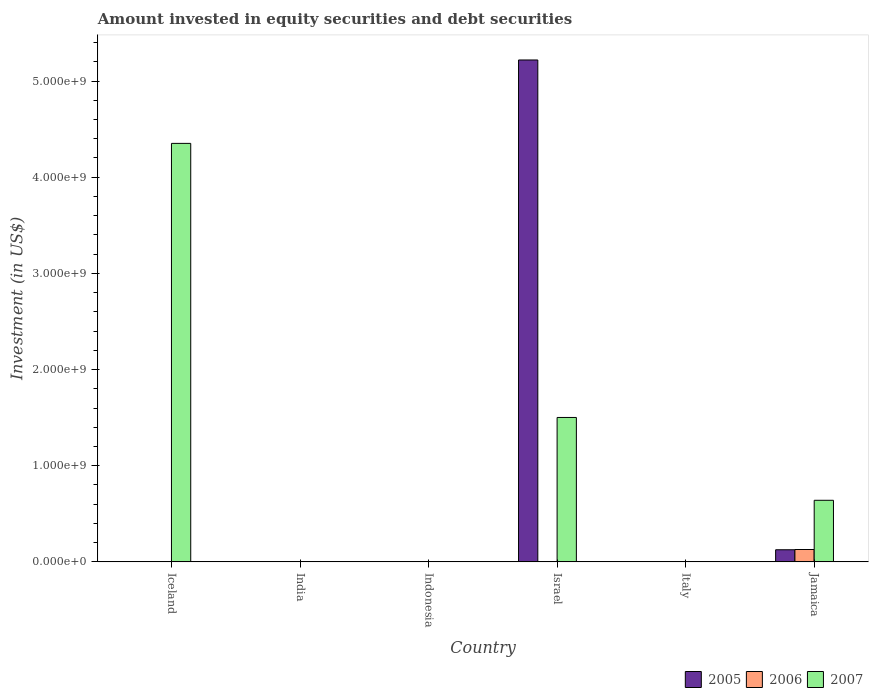How many different coloured bars are there?
Provide a succinct answer. 3. Are the number of bars per tick equal to the number of legend labels?
Provide a succinct answer. No. Are the number of bars on each tick of the X-axis equal?
Provide a short and direct response. No. How many bars are there on the 3rd tick from the left?
Your answer should be very brief. 0. How many bars are there on the 5th tick from the right?
Offer a very short reply. 0. In how many cases, is the number of bars for a given country not equal to the number of legend labels?
Offer a terse response. 5. What is the amount invested in equity securities and debt securities in 2006 in Italy?
Offer a very short reply. 0. Across all countries, what is the maximum amount invested in equity securities and debt securities in 2007?
Offer a very short reply. 4.35e+09. Across all countries, what is the minimum amount invested in equity securities and debt securities in 2007?
Offer a terse response. 0. What is the total amount invested in equity securities and debt securities in 2005 in the graph?
Provide a succinct answer. 5.34e+09. What is the difference between the amount invested in equity securities and debt securities in 2005 in Jamaica and the amount invested in equity securities and debt securities in 2006 in Iceland?
Provide a succinct answer. 1.26e+08. What is the average amount invested in equity securities and debt securities in 2005 per country?
Keep it short and to the point. 8.91e+08. What is the difference between the amount invested in equity securities and debt securities of/in 2006 and amount invested in equity securities and debt securities of/in 2005 in Jamaica?
Keep it short and to the point. 2.52e+06. In how many countries, is the amount invested in equity securities and debt securities in 2005 greater than 2000000000 US$?
Keep it short and to the point. 1. Is the amount invested in equity securities and debt securities in 2005 in Israel less than that in Jamaica?
Offer a very short reply. No. What is the difference between the highest and the second highest amount invested in equity securities and debt securities in 2007?
Give a very brief answer. -2.85e+09. What is the difference between the highest and the lowest amount invested in equity securities and debt securities in 2006?
Make the answer very short. 1.29e+08. In how many countries, is the amount invested in equity securities and debt securities in 2007 greater than the average amount invested in equity securities and debt securities in 2007 taken over all countries?
Your response must be concise. 2. Is it the case that in every country, the sum of the amount invested in equity securities and debt securities in 2007 and amount invested in equity securities and debt securities in 2006 is greater than the amount invested in equity securities and debt securities in 2005?
Provide a short and direct response. No. How many bars are there?
Offer a terse response. 6. Are all the bars in the graph horizontal?
Your response must be concise. No. Are the values on the major ticks of Y-axis written in scientific E-notation?
Your answer should be compact. Yes. Does the graph contain any zero values?
Offer a terse response. Yes. Does the graph contain grids?
Give a very brief answer. No. Where does the legend appear in the graph?
Provide a succinct answer. Bottom right. How many legend labels are there?
Your answer should be very brief. 3. How are the legend labels stacked?
Ensure brevity in your answer.  Horizontal. What is the title of the graph?
Provide a succinct answer. Amount invested in equity securities and debt securities. What is the label or title of the Y-axis?
Provide a succinct answer. Investment (in US$). What is the Investment (in US$) of 2006 in Iceland?
Offer a very short reply. 0. What is the Investment (in US$) in 2007 in Iceland?
Provide a short and direct response. 4.35e+09. What is the Investment (in US$) of 2007 in India?
Keep it short and to the point. 0. What is the Investment (in US$) of 2005 in Indonesia?
Offer a terse response. 0. What is the Investment (in US$) in 2006 in Indonesia?
Give a very brief answer. 0. What is the Investment (in US$) of 2005 in Israel?
Ensure brevity in your answer.  5.22e+09. What is the Investment (in US$) in 2006 in Israel?
Provide a short and direct response. 0. What is the Investment (in US$) of 2007 in Israel?
Offer a terse response. 1.50e+09. What is the Investment (in US$) in 2005 in Italy?
Provide a short and direct response. 0. What is the Investment (in US$) in 2006 in Italy?
Provide a succinct answer. 0. What is the Investment (in US$) of 2007 in Italy?
Provide a short and direct response. 0. What is the Investment (in US$) of 2005 in Jamaica?
Offer a terse response. 1.26e+08. What is the Investment (in US$) in 2006 in Jamaica?
Your response must be concise. 1.29e+08. What is the Investment (in US$) in 2007 in Jamaica?
Your answer should be very brief. 6.40e+08. Across all countries, what is the maximum Investment (in US$) in 2005?
Your answer should be very brief. 5.22e+09. Across all countries, what is the maximum Investment (in US$) of 2006?
Your answer should be compact. 1.29e+08. Across all countries, what is the maximum Investment (in US$) of 2007?
Offer a terse response. 4.35e+09. Across all countries, what is the minimum Investment (in US$) of 2006?
Keep it short and to the point. 0. What is the total Investment (in US$) in 2005 in the graph?
Your answer should be compact. 5.34e+09. What is the total Investment (in US$) of 2006 in the graph?
Provide a short and direct response. 1.29e+08. What is the total Investment (in US$) in 2007 in the graph?
Make the answer very short. 6.49e+09. What is the difference between the Investment (in US$) in 2007 in Iceland and that in Israel?
Offer a very short reply. 2.85e+09. What is the difference between the Investment (in US$) in 2007 in Iceland and that in Jamaica?
Your answer should be very brief. 3.71e+09. What is the difference between the Investment (in US$) of 2005 in Israel and that in Jamaica?
Offer a very short reply. 5.09e+09. What is the difference between the Investment (in US$) in 2007 in Israel and that in Jamaica?
Give a very brief answer. 8.61e+08. What is the difference between the Investment (in US$) of 2005 in Israel and the Investment (in US$) of 2006 in Jamaica?
Your response must be concise. 5.09e+09. What is the difference between the Investment (in US$) in 2005 in Israel and the Investment (in US$) in 2007 in Jamaica?
Your response must be concise. 4.58e+09. What is the average Investment (in US$) of 2005 per country?
Your answer should be very brief. 8.91e+08. What is the average Investment (in US$) in 2006 per country?
Offer a terse response. 2.14e+07. What is the average Investment (in US$) in 2007 per country?
Give a very brief answer. 1.08e+09. What is the difference between the Investment (in US$) in 2005 and Investment (in US$) in 2007 in Israel?
Give a very brief answer. 3.72e+09. What is the difference between the Investment (in US$) of 2005 and Investment (in US$) of 2006 in Jamaica?
Your response must be concise. -2.52e+06. What is the difference between the Investment (in US$) in 2005 and Investment (in US$) in 2007 in Jamaica?
Offer a terse response. -5.14e+08. What is the difference between the Investment (in US$) in 2006 and Investment (in US$) in 2007 in Jamaica?
Keep it short and to the point. -5.12e+08. What is the ratio of the Investment (in US$) of 2007 in Iceland to that in Israel?
Provide a succinct answer. 2.9. What is the ratio of the Investment (in US$) in 2007 in Iceland to that in Jamaica?
Offer a very short reply. 6.79. What is the ratio of the Investment (in US$) of 2005 in Israel to that in Jamaica?
Offer a very short reply. 41.42. What is the ratio of the Investment (in US$) of 2007 in Israel to that in Jamaica?
Your answer should be compact. 2.34. What is the difference between the highest and the second highest Investment (in US$) of 2007?
Your answer should be compact. 2.85e+09. What is the difference between the highest and the lowest Investment (in US$) in 2005?
Make the answer very short. 5.22e+09. What is the difference between the highest and the lowest Investment (in US$) in 2006?
Your answer should be very brief. 1.29e+08. What is the difference between the highest and the lowest Investment (in US$) in 2007?
Provide a succinct answer. 4.35e+09. 